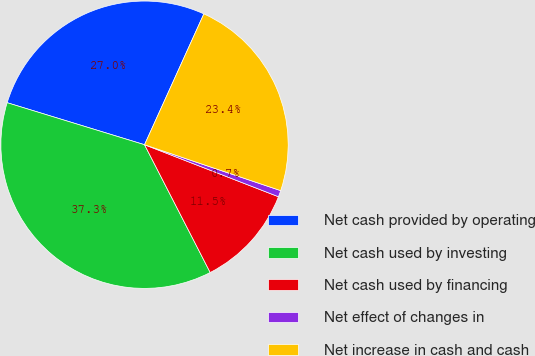Convert chart to OTSL. <chart><loc_0><loc_0><loc_500><loc_500><pie_chart><fcel>Net cash provided by operating<fcel>Net cash used by investing<fcel>Net cash used by financing<fcel>Net effect of changes in<fcel>Net increase in cash and cash<nl><fcel>27.05%<fcel>37.28%<fcel>11.55%<fcel>0.72%<fcel>23.4%<nl></chart> 